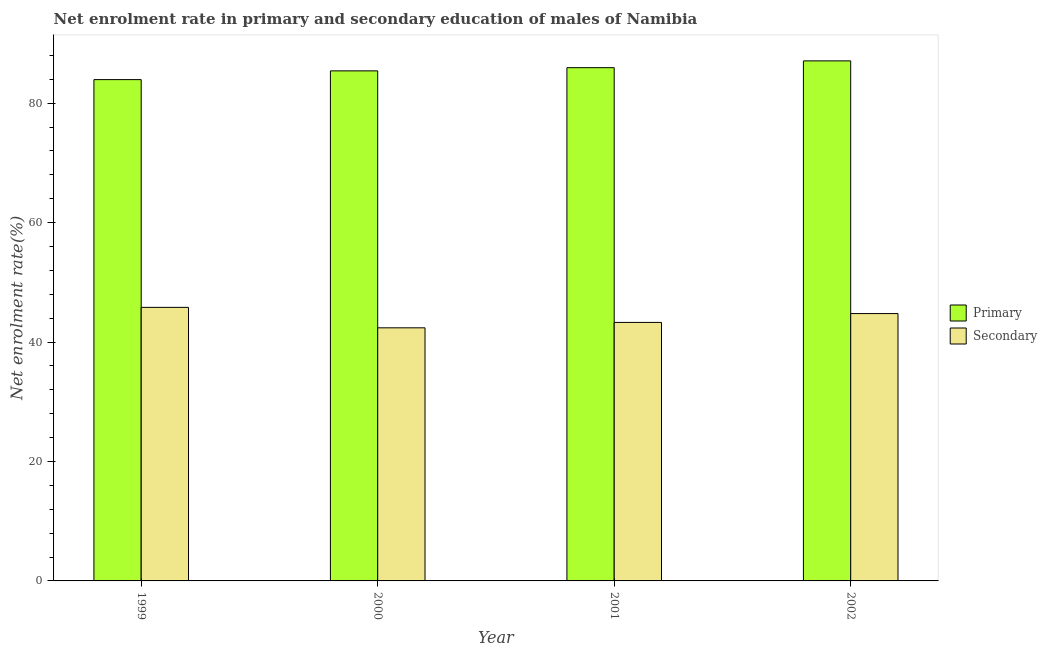How many groups of bars are there?
Your response must be concise. 4. How many bars are there on the 3rd tick from the left?
Your answer should be very brief. 2. In how many cases, is the number of bars for a given year not equal to the number of legend labels?
Your response must be concise. 0. What is the enrollment rate in secondary education in 2000?
Your answer should be compact. 42.39. Across all years, what is the maximum enrollment rate in secondary education?
Keep it short and to the point. 45.81. Across all years, what is the minimum enrollment rate in secondary education?
Your answer should be very brief. 42.39. In which year was the enrollment rate in secondary education maximum?
Keep it short and to the point. 1999. What is the total enrollment rate in primary education in the graph?
Your answer should be compact. 342.42. What is the difference between the enrollment rate in secondary education in 2000 and that in 2002?
Make the answer very short. -2.39. What is the difference between the enrollment rate in secondary education in 2001 and the enrollment rate in primary education in 2002?
Provide a short and direct response. -1.48. What is the average enrollment rate in secondary education per year?
Offer a very short reply. 44.07. In how many years, is the enrollment rate in primary education greater than 24 %?
Keep it short and to the point. 4. What is the ratio of the enrollment rate in primary education in 1999 to that in 2000?
Offer a very short reply. 0.98. Is the enrollment rate in primary education in 2000 less than that in 2001?
Provide a short and direct response. Yes. What is the difference between the highest and the second highest enrollment rate in primary education?
Offer a terse response. 1.14. What is the difference between the highest and the lowest enrollment rate in primary education?
Your response must be concise. 3.14. What does the 2nd bar from the left in 1999 represents?
Provide a short and direct response. Secondary. What does the 2nd bar from the right in 1999 represents?
Provide a short and direct response. Primary. What is the difference between two consecutive major ticks on the Y-axis?
Your response must be concise. 20. Does the graph contain grids?
Your answer should be compact. No. Where does the legend appear in the graph?
Keep it short and to the point. Center right. What is the title of the graph?
Your response must be concise. Net enrolment rate in primary and secondary education of males of Namibia. What is the label or title of the X-axis?
Offer a very short reply. Year. What is the label or title of the Y-axis?
Ensure brevity in your answer.  Net enrolment rate(%). What is the Net enrolment rate(%) of Primary in 1999?
Keep it short and to the point. 83.95. What is the Net enrolment rate(%) of Secondary in 1999?
Provide a succinct answer. 45.81. What is the Net enrolment rate(%) in Primary in 2000?
Keep it short and to the point. 85.42. What is the Net enrolment rate(%) of Secondary in 2000?
Offer a terse response. 42.39. What is the Net enrolment rate(%) in Primary in 2001?
Your answer should be very brief. 85.95. What is the Net enrolment rate(%) of Secondary in 2001?
Make the answer very short. 43.29. What is the Net enrolment rate(%) of Primary in 2002?
Give a very brief answer. 87.09. What is the Net enrolment rate(%) of Secondary in 2002?
Your answer should be compact. 44.77. Across all years, what is the maximum Net enrolment rate(%) of Primary?
Your answer should be very brief. 87.09. Across all years, what is the maximum Net enrolment rate(%) of Secondary?
Provide a succinct answer. 45.81. Across all years, what is the minimum Net enrolment rate(%) in Primary?
Provide a succinct answer. 83.95. Across all years, what is the minimum Net enrolment rate(%) in Secondary?
Your answer should be very brief. 42.39. What is the total Net enrolment rate(%) in Primary in the graph?
Your answer should be very brief. 342.42. What is the total Net enrolment rate(%) in Secondary in the graph?
Your answer should be very brief. 176.26. What is the difference between the Net enrolment rate(%) in Primary in 1999 and that in 2000?
Provide a succinct answer. -1.47. What is the difference between the Net enrolment rate(%) in Secondary in 1999 and that in 2000?
Your response must be concise. 3.42. What is the difference between the Net enrolment rate(%) of Primary in 1999 and that in 2001?
Provide a succinct answer. -2. What is the difference between the Net enrolment rate(%) in Secondary in 1999 and that in 2001?
Provide a succinct answer. 2.52. What is the difference between the Net enrolment rate(%) in Primary in 1999 and that in 2002?
Ensure brevity in your answer.  -3.14. What is the difference between the Net enrolment rate(%) of Secondary in 1999 and that in 2002?
Your response must be concise. 1.04. What is the difference between the Net enrolment rate(%) in Primary in 2000 and that in 2001?
Your answer should be very brief. -0.53. What is the difference between the Net enrolment rate(%) in Secondary in 2000 and that in 2001?
Provide a succinct answer. -0.91. What is the difference between the Net enrolment rate(%) of Primary in 2000 and that in 2002?
Offer a terse response. -1.67. What is the difference between the Net enrolment rate(%) of Secondary in 2000 and that in 2002?
Offer a very short reply. -2.39. What is the difference between the Net enrolment rate(%) in Primary in 2001 and that in 2002?
Provide a short and direct response. -1.14. What is the difference between the Net enrolment rate(%) of Secondary in 2001 and that in 2002?
Keep it short and to the point. -1.48. What is the difference between the Net enrolment rate(%) of Primary in 1999 and the Net enrolment rate(%) of Secondary in 2000?
Keep it short and to the point. 41.57. What is the difference between the Net enrolment rate(%) of Primary in 1999 and the Net enrolment rate(%) of Secondary in 2001?
Ensure brevity in your answer.  40.66. What is the difference between the Net enrolment rate(%) in Primary in 1999 and the Net enrolment rate(%) in Secondary in 2002?
Give a very brief answer. 39.18. What is the difference between the Net enrolment rate(%) of Primary in 2000 and the Net enrolment rate(%) of Secondary in 2001?
Your response must be concise. 42.13. What is the difference between the Net enrolment rate(%) in Primary in 2000 and the Net enrolment rate(%) in Secondary in 2002?
Give a very brief answer. 40.65. What is the difference between the Net enrolment rate(%) of Primary in 2001 and the Net enrolment rate(%) of Secondary in 2002?
Ensure brevity in your answer.  41.18. What is the average Net enrolment rate(%) in Primary per year?
Offer a very short reply. 85.61. What is the average Net enrolment rate(%) in Secondary per year?
Keep it short and to the point. 44.07. In the year 1999, what is the difference between the Net enrolment rate(%) of Primary and Net enrolment rate(%) of Secondary?
Give a very brief answer. 38.14. In the year 2000, what is the difference between the Net enrolment rate(%) in Primary and Net enrolment rate(%) in Secondary?
Your answer should be compact. 43.03. In the year 2001, what is the difference between the Net enrolment rate(%) in Primary and Net enrolment rate(%) in Secondary?
Offer a terse response. 42.66. In the year 2002, what is the difference between the Net enrolment rate(%) in Primary and Net enrolment rate(%) in Secondary?
Provide a short and direct response. 42.32. What is the ratio of the Net enrolment rate(%) of Primary in 1999 to that in 2000?
Your response must be concise. 0.98. What is the ratio of the Net enrolment rate(%) in Secondary in 1999 to that in 2000?
Provide a succinct answer. 1.08. What is the ratio of the Net enrolment rate(%) of Primary in 1999 to that in 2001?
Provide a succinct answer. 0.98. What is the ratio of the Net enrolment rate(%) in Secondary in 1999 to that in 2001?
Keep it short and to the point. 1.06. What is the ratio of the Net enrolment rate(%) of Primary in 1999 to that in 2002?
Provide a succinct answer. 0.96. What is the ratio of the Net enrolment rate(%) of Secondary in 1999 to that in 2002?
Keep it short and to the point. 1.02. What is the ratio of the Net enrolment rate(%) in Primary in 2000 to that in 2001?
Provide a short and direct response. 0.99. What is the ratio of the Net enrolment rate(%) in Secondary in 2000 to that in 2001?
Offer a very short reply. 0.98. What is the ratio of the Net enrolment rate(%) in Primary in 2000 to that in 2002?
Make the answer very short. 0.98. What is the ratio of the Net enrolment rate(%) in Secondary in 2000 to that in 2002?
Make the answer very short. 0.95. What is the ratio of the Net enrolment rate(%) in Primary in 2001 to that in 2002?
Give a very brief answer. 0.99. What is the ratio of the Net enrolment rate(%) of Secondary in 2001 to that in 2002?
Ensure brevity in your answer.  0.97. What is the difference between the highest and the second highest Net enrolment rate(%) in Primary?
Your response must be concise. 1.14. What is the difference between the highest and the second highest Net enrolment rate(%) in Secondary?
Provide a short and direct response. 1.04. What is the difference between the highest and the lowest Net enrolment rate(%) of Primary?
Make the answer very short. 3.14. What is the difference between the highest and the lowest Net enrolment rate(%) in Secondary?
Offer a very short reply. 3.42. 